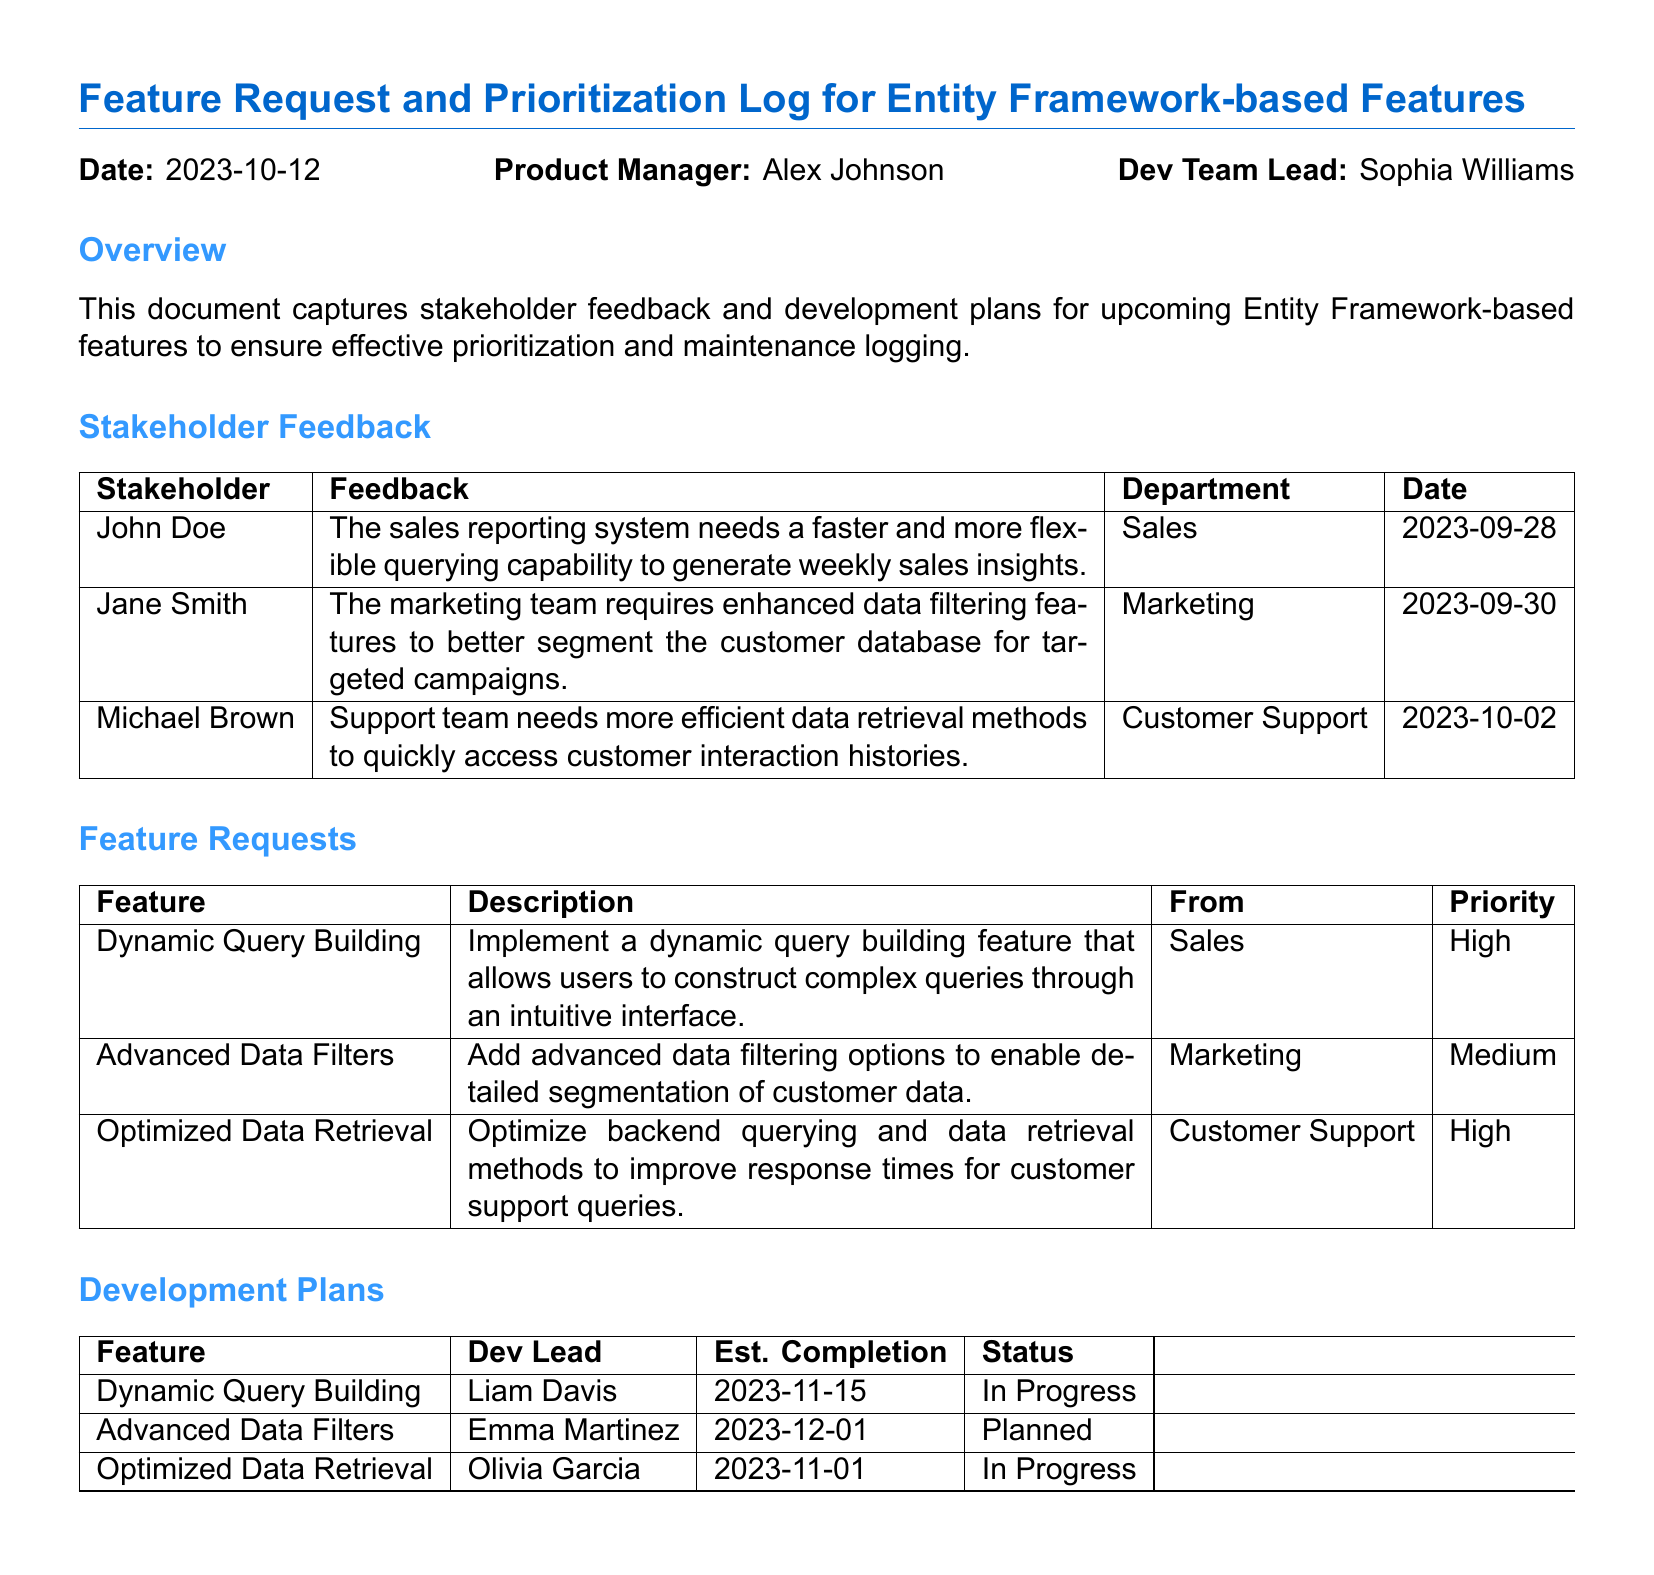What is the date of this document? The date of the document is explicitly mentioned in the header, which is 2023-10-12.
Answer: 2023-10-12 Who is the product manager? The product manager is specified in the document header as Alex Johnson.
Answer: Alex Johnson What is the priority of the Dynamic Query Building feature? The priority for the Dynamic Query Building feature is listed under the Feature Requests section as High.
Answer: High Which department requested the Advanced Data Filters feature? The Advanced Data Filters feature is requested by the Marketing department, as indicated in the Feature Requests section.
Answer: Marketing What is the estimated completion date for the Optimized Data Retrieval feature? The estimated completion date for the Optimized Data Retrieval feature is stated in the Development Plans section as 2023-11-01.
Answer: 2023-11-01 Who is the development lead for Advanced Data Filters? The development lead for Advanced Data Filters is listed as Emma Martinez in the Development Plans section.
Answer: Emma Martinez What feedback did Michael Brown provide? Michael Brown's feedback is noted in the Stakeholder Feedback section, stating that the support team needs more efficient data retrieval methods.
Answer: More efficient data retrieval methods How many features are categorized as High priority? There are two features categorized as High priority: Dynamic Query Building and Optimized Data Retrieval.
Answer: Two What is the status of the Advanced Data Filters feature? The status of the Advanced Data Filters feature is noted in the Development Plans section as Planned.
Answer: Planned 